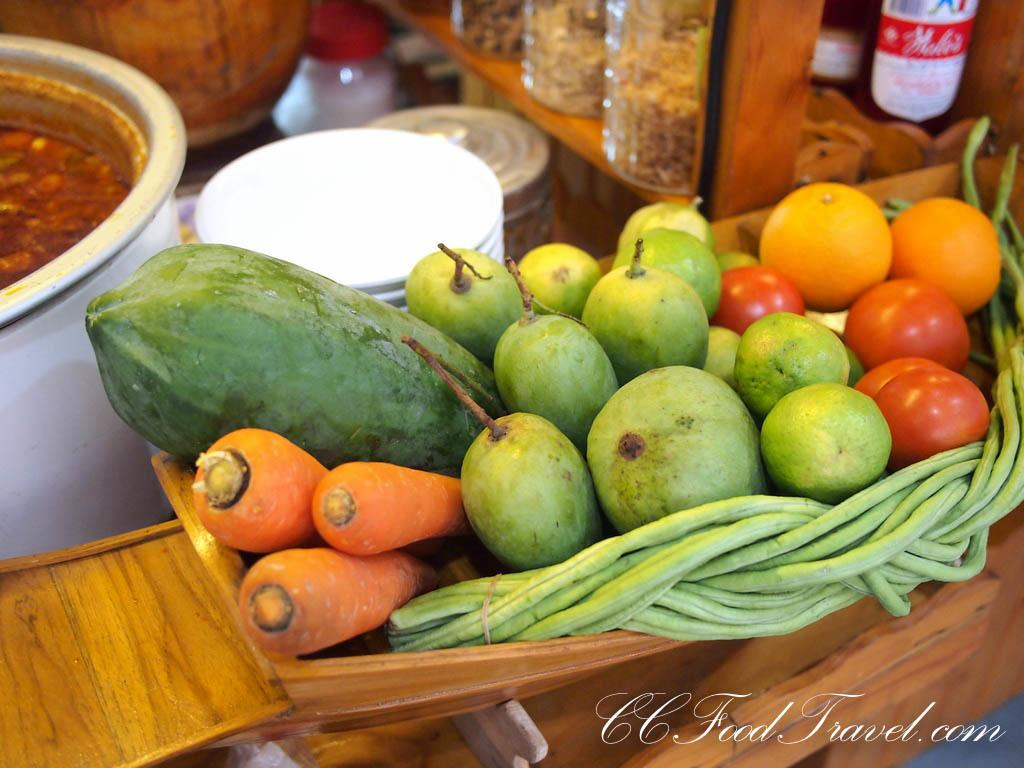What type of food items are in the basket in the image? There are vegetables in a basket in the image. What is located to the left of the basket? There is a bowl to the left of the basket. What can be seen in the background of the image? There are jars and boxes in the background of the image. What material is the table made of? The table is made of wood. What verse is being recited by the vegetables in the image? There are no verses or any form of communication being depicted by the vegetables in the image. 